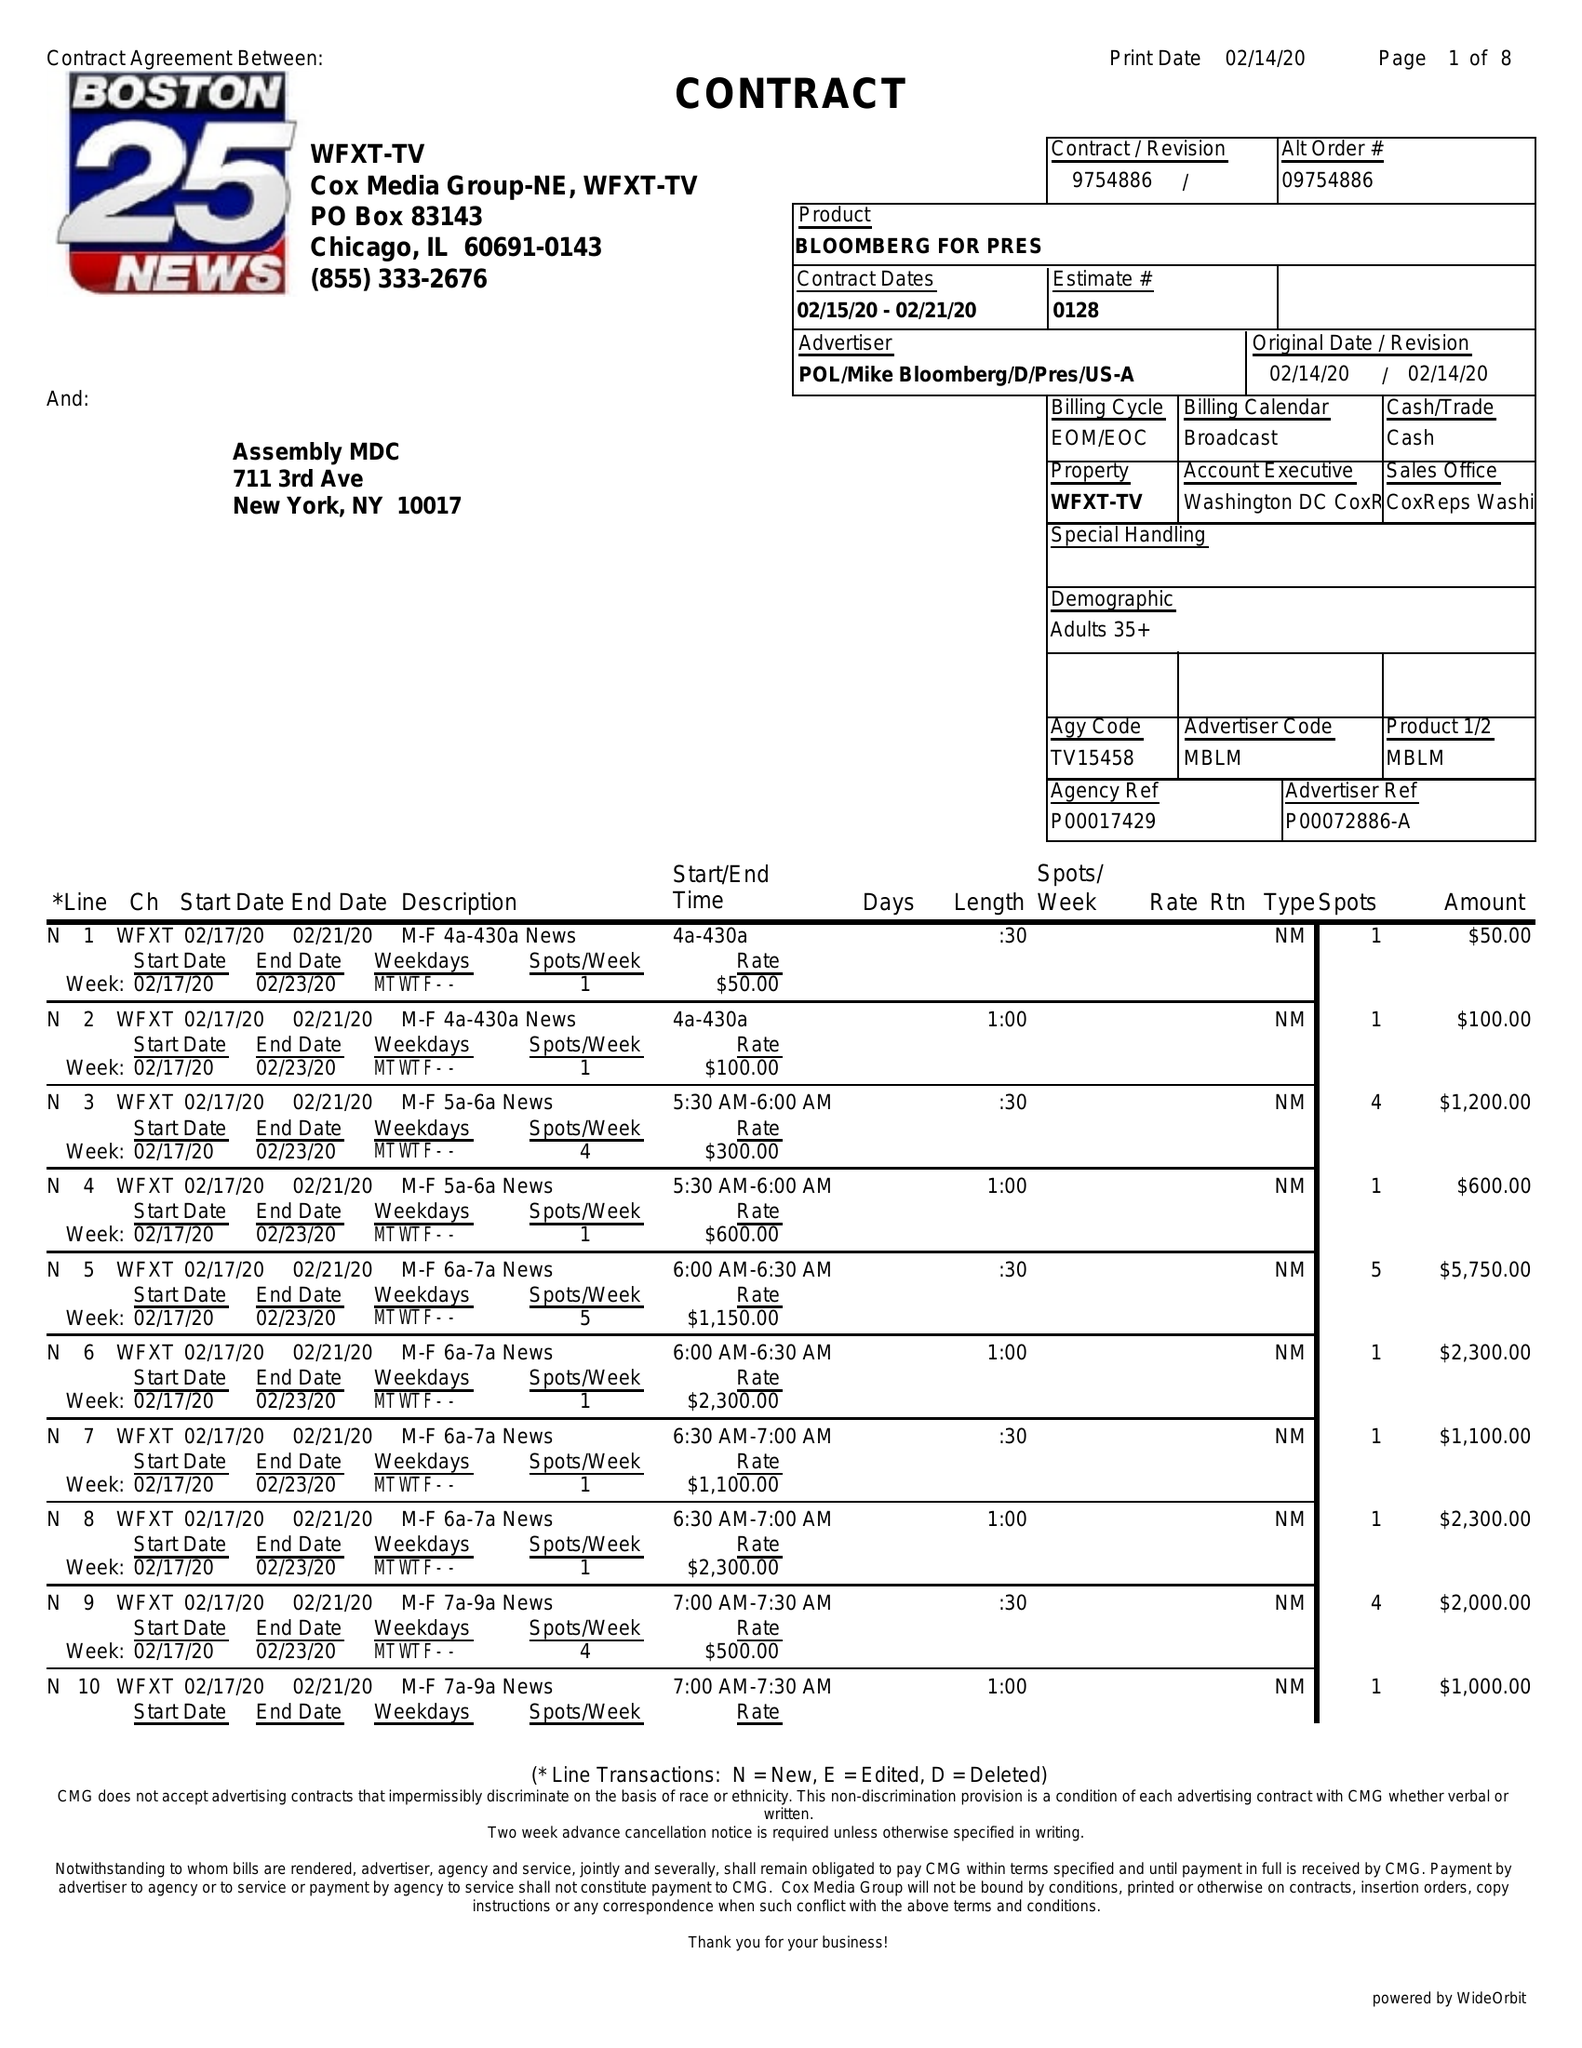What is the value for the flight_from?
Answer the question using a single word or phrase. 02/15/20 